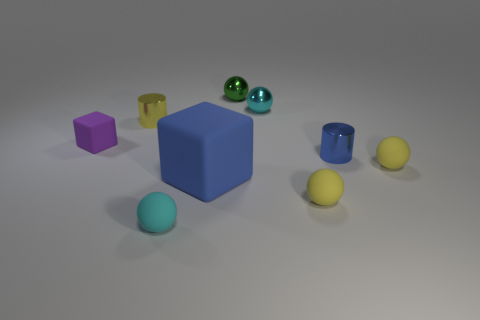Subtract all tiny rubber spheres. How many spheres are left? 2 Subtract 2 blocks. How many blocks are left? 0 Add 1 green metallic things. How many objects exist? 10 Subtract all yellow cylinders. How many cylinders are left? 1 Add 5 small purple objects. How many small purple objects are left? 6 Add 1 small purple things. How many small purple things exist? 2 Subtract 0 red cylinders. How many objects are left? 9 Subtract all spheres. How many objects are left? 4 Subtract all cyan cubes. Subtract all brown balls. How many cubes are left? 2 Subtract all brown spheres. How many purple blocks are left? 1 